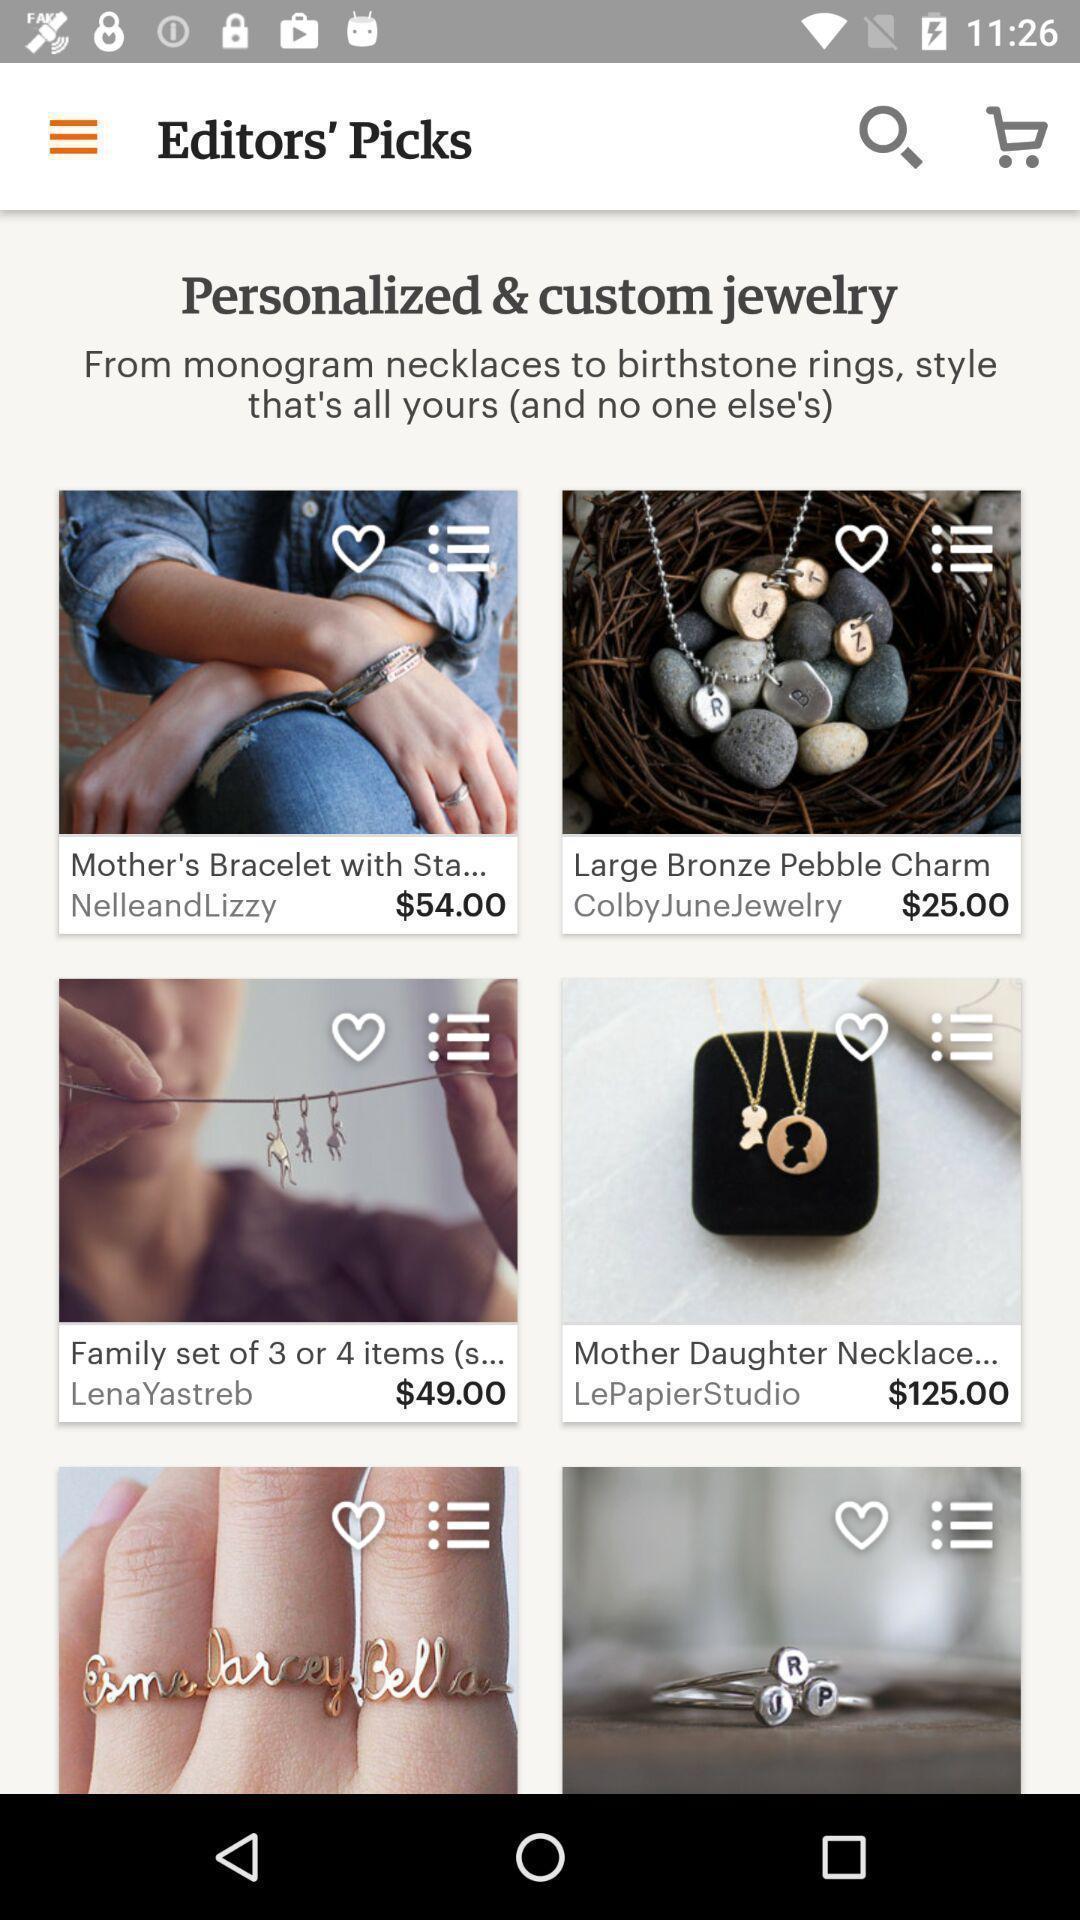Describe the visual elements of this screenshot. Page showing search icon to find handmade products. 